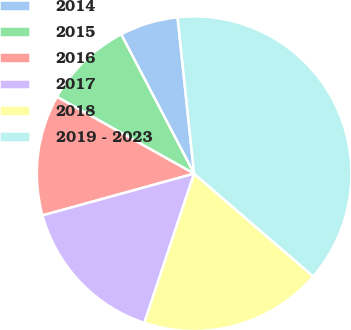Convert chart to OTSL. <chart><loc_0><loc_0><loc_500><loc_500><pie_chart><fcel>2014<fcel>2015<fcel>2016<fcel>2017<fcel>2018<fcel>2019 - 2023<nl><fcel>6.0%<fcel>9.2%<fcel>12.4%<fcel>15.6%<fcel>18.8%<fcel>38.0%<nl></chart> 